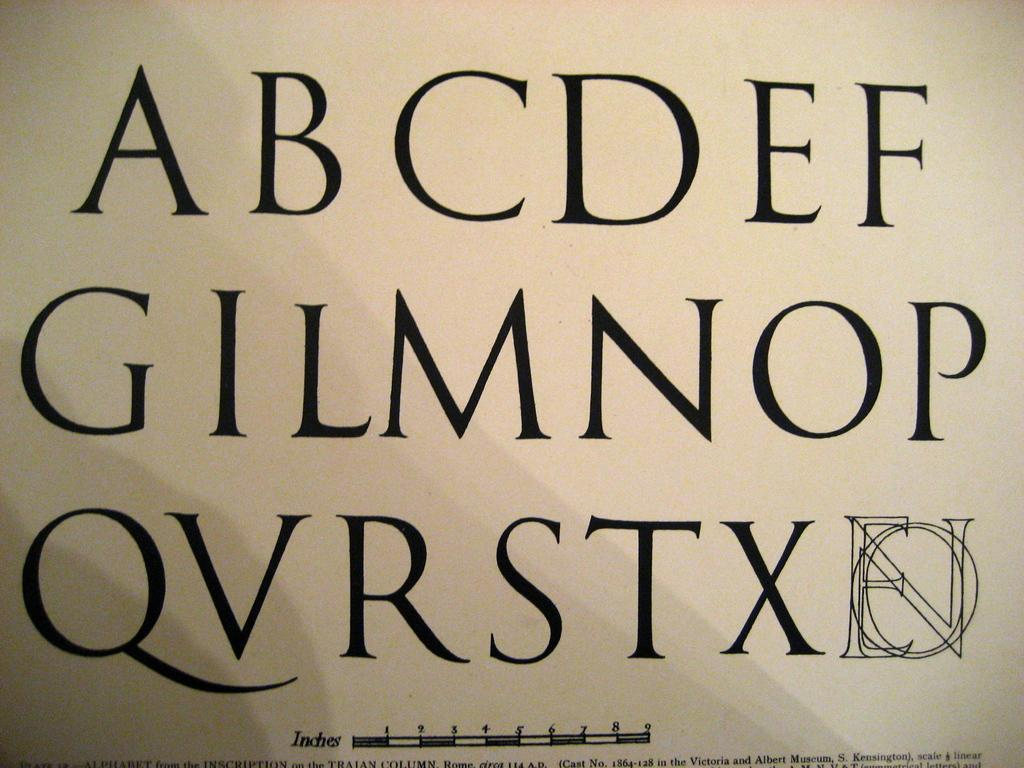<image>
Create a compact narrative representing the image presented. The alphabet printed in large black text with letters A-F on the first line. 